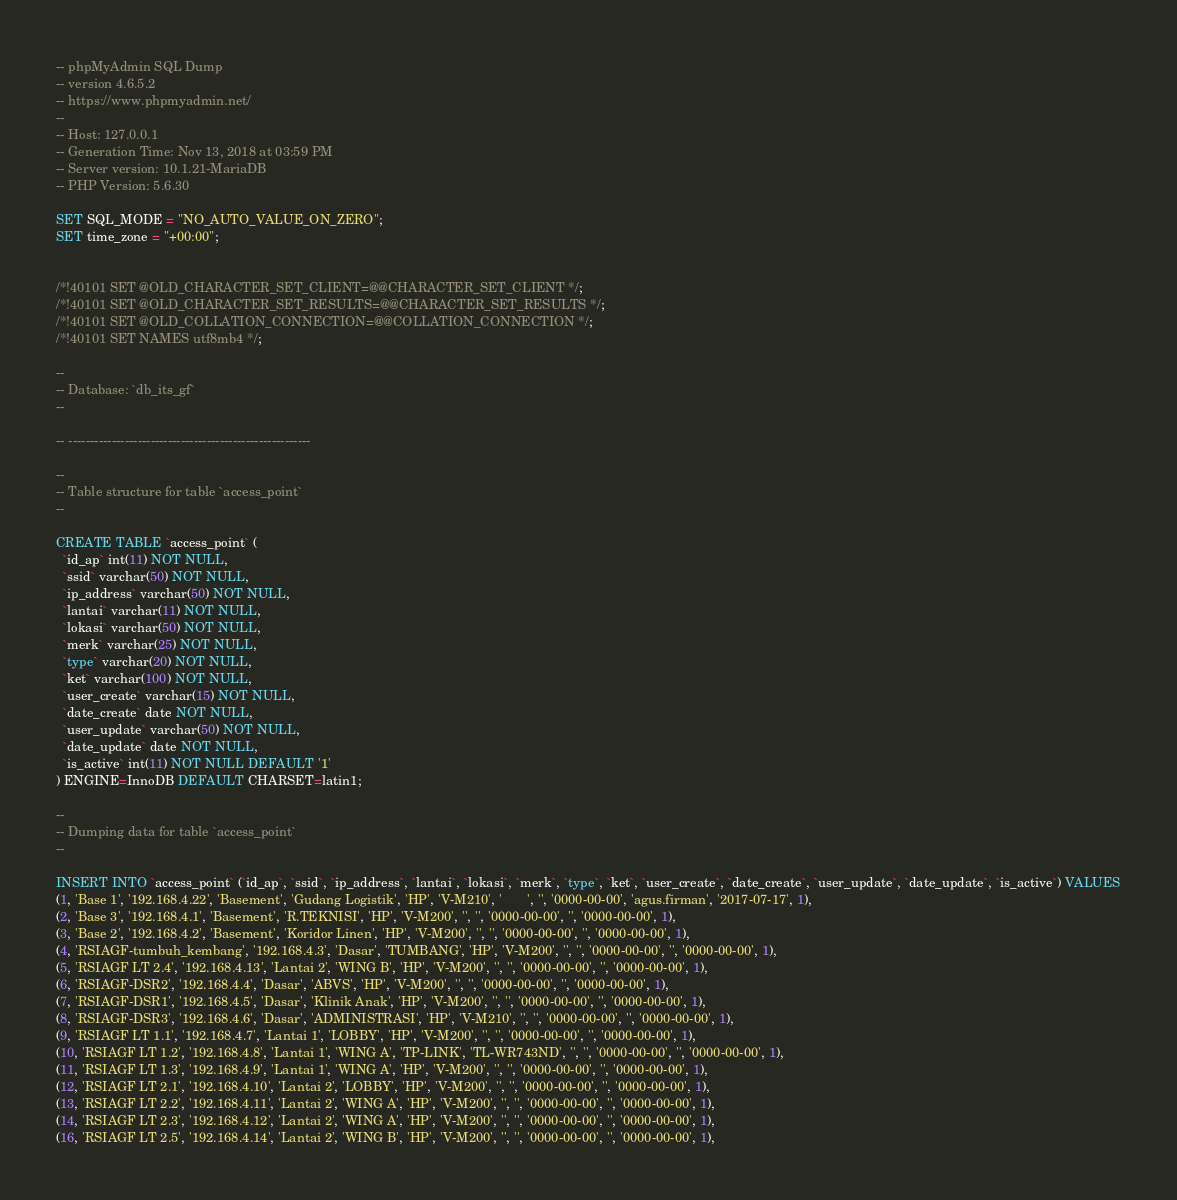Convert code to text. <code><loc_0><loc_0><loc_500><loc_500><_SQL_>-- phpMyAdmin SQL Dump
-- version 4.6.5.2
-- https://www.phpmyadmin.net/
--
-- Host: 127.0.0.1
-- Generation Time: Nov 13, 2018 at 03:59 PM
-- Server version: 10.1.21-MariaDB
-- PHP Version: 5.6.30

SET SQL_MODE = "NO_AUTO_VALUE_ON_ZERO";
SET time_zone = "+00:00";


/*!40101 SET @OLD_CHARACTER_SET_CLIENT=@@CHARACTER_SET_CLIENT */;
/*!40101 SET @OLD_CHARACTER_SET_RESULTS=@@CHARACTER_SET_RESULTS */;
/*!40101 SET @OLD_COLLATION_CONNECTION=@@COLLATION_CONNECTION */;
/*!40101 SET NAMES utf8mb4 */;

--
-- Database: `db_its_gf`
--

-- --------------------------------------------------------

--
-- Table structure for table `access_point`
--

CREATE TABLE `access_point` (
  `id_ap` int(11) NOT NULL,
  `ssid` varchar(50) NOT NULL,
  `ip_address` varchar(50) NOT NULL,
  `lantai` varchar(11) NOT NULL,
  `lokasi` varchar(50) NOT NULL,
  `merk` varchar(25) NOT NULL,
  `type` varchar(20) NOT NULL,
  `ket` varchar(100) NOT NULL,
  `user_create` varchar(15) NOT NULL,
  `date_create` date NOT NULL,
  `user_update` varchar(50) NOT NULL,
  `date_update` date NOT NULL,
  `is_active` int(11) NOT NULL DEFAULT '1'
) ENGINE=InnoDB DEFAULT CHARSET=latin1;

--
-- Dumping data for table `access_point`
--

INSERT INTO `access_point` (`id_ap`, `ssid`, `ip_address`, `lantai`, `lokasi`, `merk`, `type`, `ket`, `user_create`, `date_create`, `user_update`, `date_update`, `is_active`) VALUES
(1, 'Base 1', '192.168.4.22', 'Basement', 'Gudang Logistik', 'HP', 'V-M210', '		', '', '0000-00-00', 'agus.firman', '2017-07-17', 1),
(2, 'Base 3', '192.168.4.1', 'Basement', 'R.TEKNISI', 'HP', 'V-M200', '', '', '0000-00-00', '', '0000-00-00', 1),
(3, 'Base 2', '192.168.4.2', 'Basement', 'Koridor Linen', 'HP', 'V-M200', '', '', '0000-00-00', '', '0000-00-00', 1),
(4, 'RSIAGF-tumbuh_kembang', '192.168.4.3', 'Dasar', 'TUMBANG', 'HP', 'V-M200', '', '', '0000-00-00', '', '0000-00-00', 1),
(5, 'RSIAGF LT 2.4', '192.168.4.13', 'Lantai 2', 'WING B', 'HP', 'V-M200', '', '', '0000-00-00', '', '0000-00-00', 1),
(6, 'RSIAGF-DSR2', '192.168.4.4', 'Dasar', 'ABVS', 'HP', 'V-M200', '', '', '0000-00-00', '', '0000-00-00', 1),
(7, 'RSIAGF-DSR1', '192.168.4.5', 'Dasar', 'Klinik Anak', 'HP', 'V-M200', '', '', '0000-00-00', '', '0000-00-00', 1),
(8, 'RSIAGF-DSR3', '192.168.4.6', 'Dasar', 'ADMINISTRASI', 'HP', 'V-M210', '', '', '0000-00-00', '', '0000-00-00', 1),
(9, 'RSIAGF LT 1.1', '192.168.4.7', 'Lantai 1', 'LOBBY', 'HP', 'V-M200', '', '', '0000-00-00', '', '0000-00-00', 1),
(10, 'RSIAGF LT 1.2', '192.168.4.8', 'Lantai 1', 'WING A', 'TP-LINK', 'TL-WR743ND', '', '', '0000-00-00', '', '0000-00-00', 1),
(11, 'RSIAGF LT 1.3', '192.168.4.9', 'Lantai 1', 'WING A', 'HP', 'V-M200', '', '', '0000-00-00', '', '0000-00-00', 1),
(12, 'RSIAGF LT 2.1', '192.168.4.10', 'Lantai 2', 'LOBBY', 'HP', 'V-M200', '', '', '0000-00-00', '', '0000-00-00', 1),
(13, 'RSIAGF LT 2.2', '192.168.4.11', 'Lantai 2', 'WING A', 'HP', 'V-M200', '', '', '0000-00-00', '', '0000-00-00', 1),
(14, 'RSIAGF LT 2.3', '192.168.4.12', 'Lantai 2', 'WING A', 'HP', 'V-M200', '', '', '0000-00-00', '', '0000-00-00', 1),
(16, 'RSIAGF LT 2.5', '192.168.4.14', 'Lantai 2', 'WING B', 'HP', 'V-M200', '', '', '0000-00-00', '', '0000-00-00', 1),</code> 